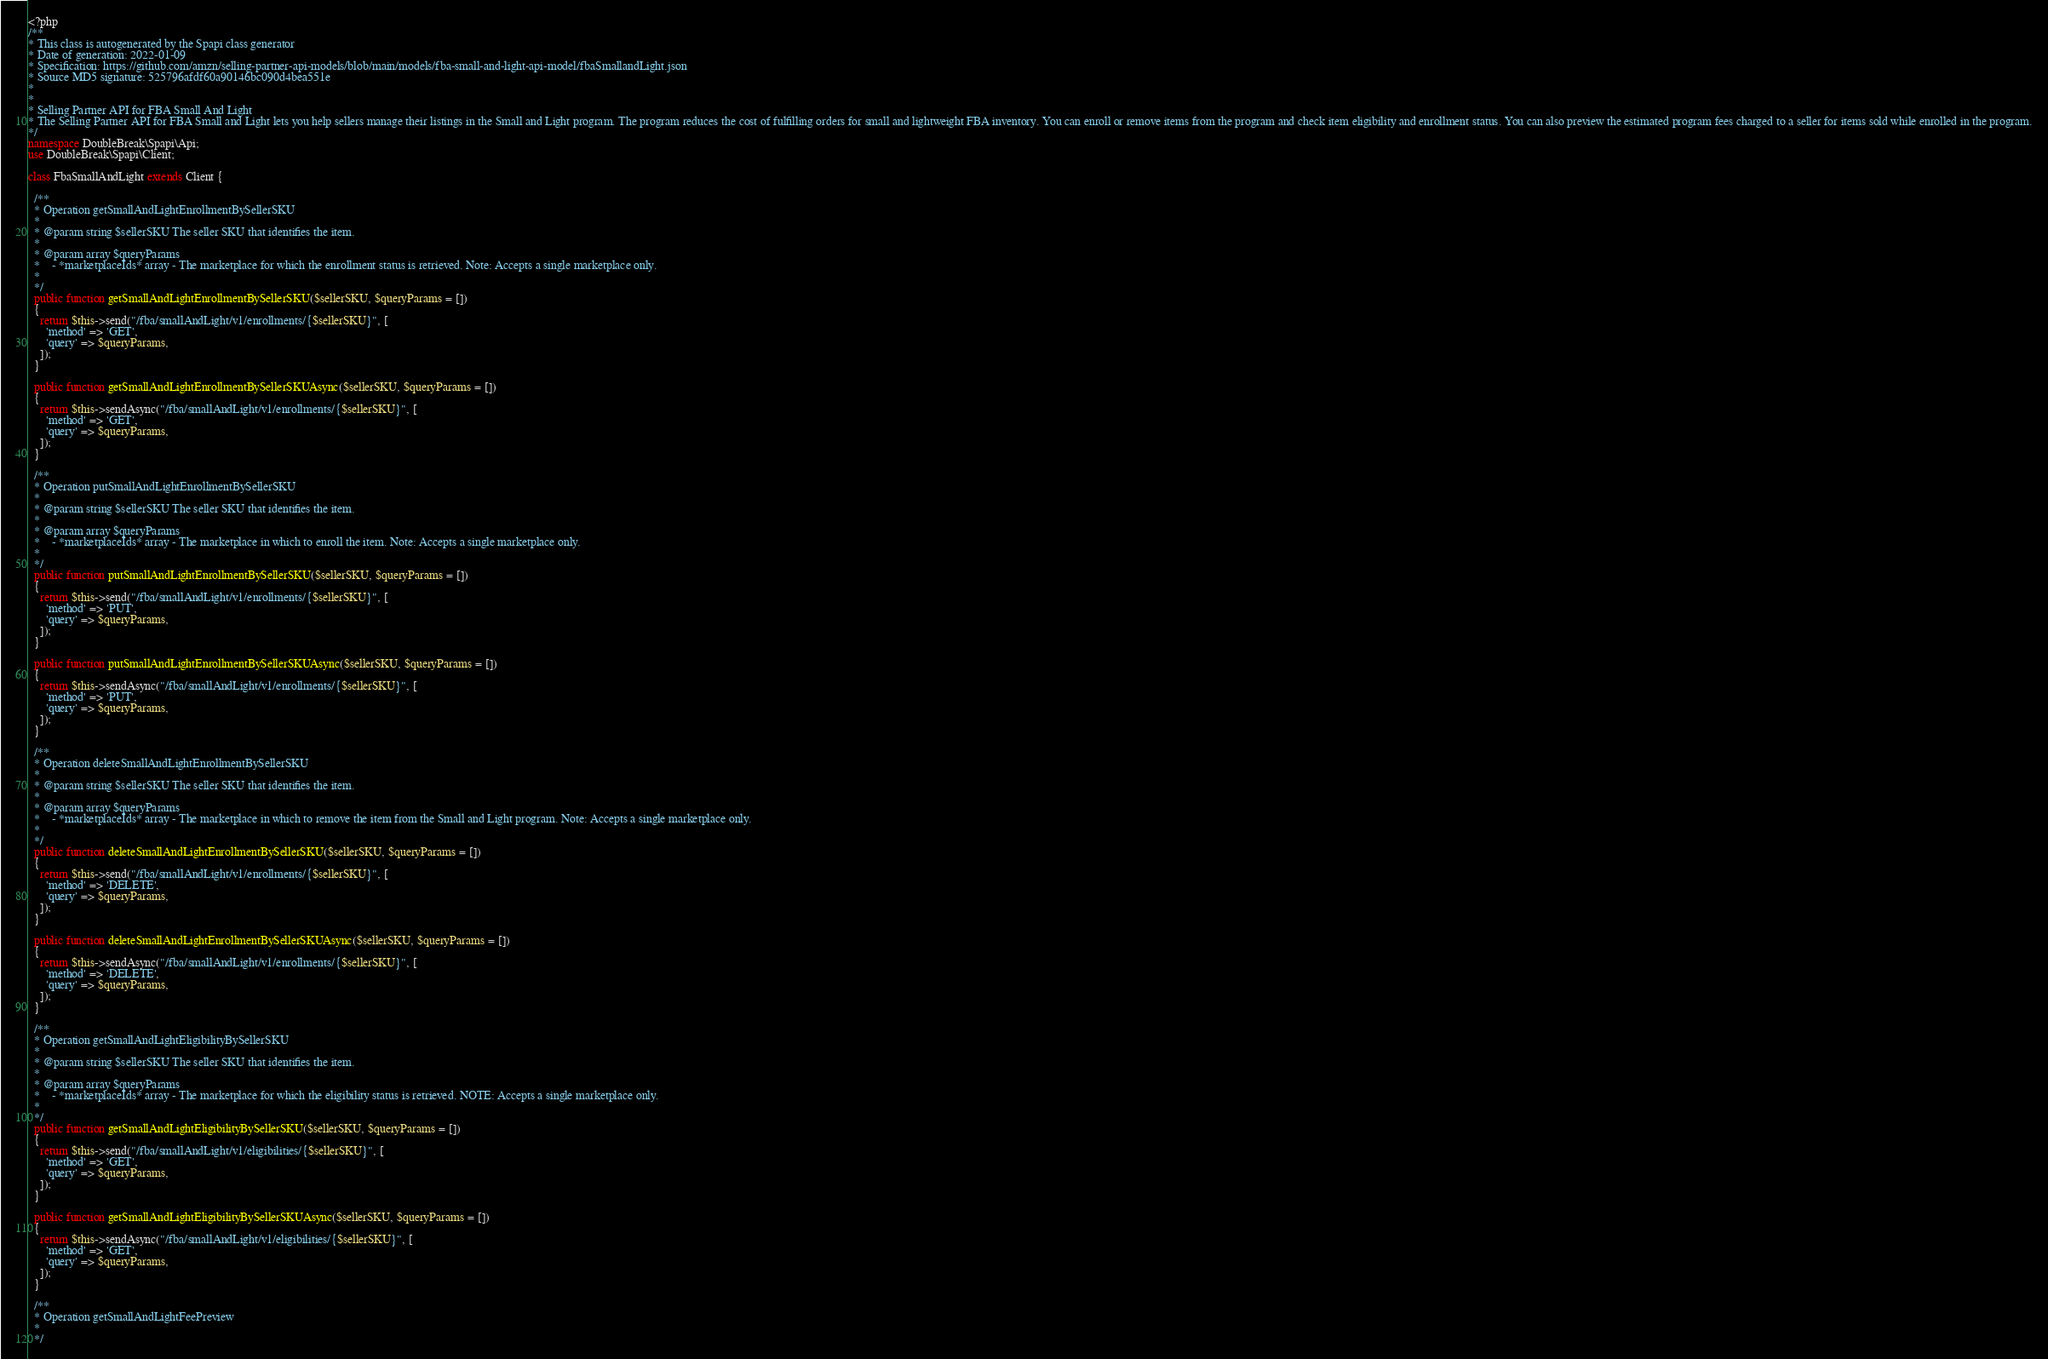<code> <loc_0><loc_0><loc_500><loc_500><_PHP_><?php
/**
* This class is autogenerated by the Spapi class generator
* Date of generation: 2022-01-09
* Specification: https://github.com/amzn/selling-partner-api-models/blob/main/models/fba-small-and-light-api-model/fbaSmallandLight.json
* Source MD5 signature: 525796afdf60a90146bc090d4bea551e
*
*
* Selling Partner API for FBA Small And Light
* The Selling Partner API for FBA Small and Light lets you help sellers manage their listings in the Small and Light program. The program reduces the cost of fulfilling orders for small and lightweight FBA inventory. You can enroll or remove items from the program and check item eligibility and enrollment status. You can also preview the estimated program fees charged to a seller for items sold while enrolled in the program.
*/
namespace DoubleBreak\Spapi\Api;
use DoubleBreak\Spapi\Client;

class FbaSmallAndLight extends Client {

  /**
  * Operation getSmallAndLightEnrollmentBySellerSKU
  *
  * @param string $sellerSKU The seller SKU that identifies the item.
  *
  * @param array $queryParams
  *    - *marketplaceIds* array - The marketplace for which the enrollment status is retrieved. Note: Accepts a single marketplace only.
  *
  */
  public function getSmallAndLightEnrollmentBySellerSKU($sellerSKU, $queryParams = [])
  {
    return $this->send("/fba/smallAndLight/v1/enrollments/{$sellerSKU}", [
      'method' => 'GET',
      'query' => $queryParams,
    ]);
  }

  public function getSmallAndLightEnrollmentBySellerSKUAsync($sellerSKU, $queryParams = [])
  {
    return $this->sendAsync("/fba/smallAndLight/v1/enrollments/{$sellerSKU}", [
      'method' => 'GET',
      'query' => $queryParams,
    ]);
  }

  /**
  * Operation putSmallAndLightEnrollmentBySellerSKU
  *
  * @param string $sellerSKU The seller SKU that identifies the item.
  *
  * @param array $queryParams
  *    - *marketplaceIds* array - The marketplace in which to enroll the item. Note: Accepts a single marketplace only.
  *
  */
  public function putSmallAndLightEnrollmentBySellerSKU($sellerSKU, $queryParams = [])
  {
    return $this->send("/fba/smallAndLight/v1/enrollments/{$sellerSKU}", [
      'method' => 'PUT',
      'query' => $queryParams,
    ]);
  }

  public function putSmallAndLightEnrollmentBySellerSKUAsync($sellerSKU, $queryParams = [])
  {
    return $this->sendAsync("/fba/smallAndLight/v1/enrollments/{$sellerSKU}", [
      'method' => 'PUT',
      'query' => $queryParams,
    ]);
  }

  /**
  * Operation deleteSmallAndLightEnrollmentBySellerSKU
  *
  * @param string $sellerSKU The seller SKU that identifies the item.
  *
  * @param array $queryParams
  *    - *marketplaceIds* array - The marketplace in which to remove the item from the Small and Light program. Note: Accepts a single marketplace only.
  *
  */
  public function deleteSmallAndLightEnrollmentBySellerSKU($sellerSKU, $queryParams = [])
  {
    return $this->send("/fba/smallAndLight/v1/enrollments/{$sellerSKU}", [
      'method' => 'DELETE',
      'query' => $queryParams,
    ]);
  }

  public function deleteSmallAndLightEnrollmentBySellerSKUAsync($sellerSKU, $queryParams = [])
  {
    return $this->sendAsync("/fba/smallAndLight/v1/enrollments/{$sellerSKU}", [
      'method' => 'DELETE',
      'query' => $queryParams,
    ]);
  }

  /**
  * Operation getSmallAndLightEligibilityBySellerSKU
  *
  * @param string $sellerSKU The seller SKU that identifies the item.
  *
  * @param array $queryParams
  *    - *marketplaceIds* array - The marketplace for which the eligibility status is retrieved. NOTE: Accepts a single marketplace only.
  *
  */
  public function getSmallAndLightEligibilityBySellerSKU($sellerSKU, $queryParams = [])
  {
    return $this->send("/fba/smallAndLight/v1/eligibilities/{$sellerSKU}", [
      'method' => 'GET',
      'query' => $queryParams,
    ]);
  }

  public function getSmallAndLightEligibilityBySellerSKUAsync($sellerSKU, $queryParams = [])
  {
    return $this->sendAsync("/fba/smallAndLight/v1/eligibilities/{$sellerSKU}", [
      'method' => 'GET',
      'query' => $queryParams,
    ]);
  }

  /**
  * Operation getSmallAndLightFeePreview
  *
  */</code> 